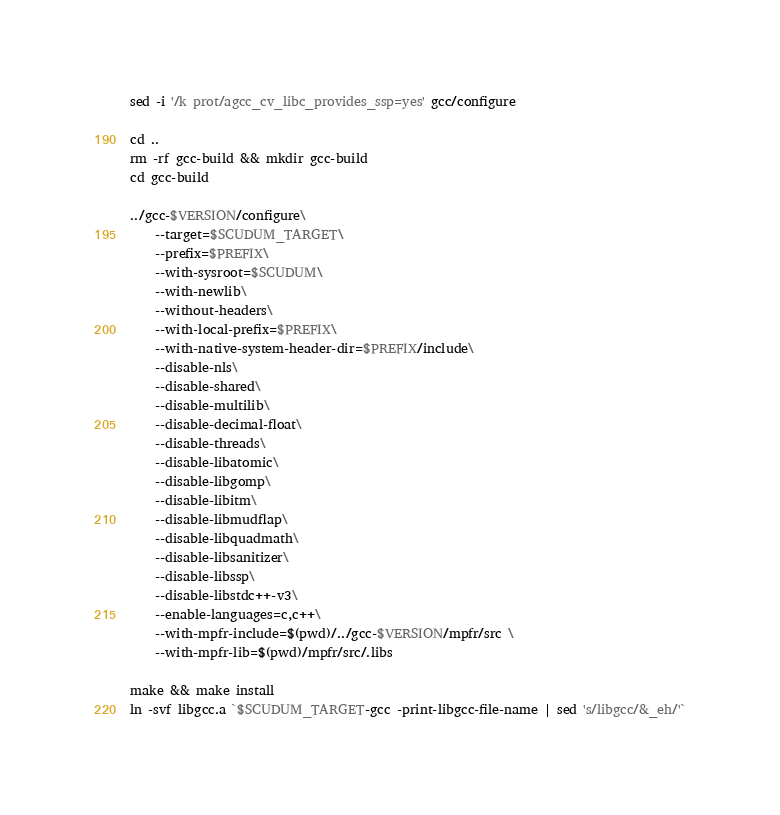<code> <loc_0><loc_0><loc_500><loc_500><_Bash_>sed -i '/k prot/agcc_cv_libc_provides_ssp=yes' gcc/configure

cd ..
rm -rf gcc-build && mkdir gcc-build
cd gcc-build

../gcc-$VERSION/configure\
    --target=$SCUDUM_TARGET\
    --prefix=$PREFIX\
    --with-sysroot=$SCUDUM\
    --with-newlib\
    --without-headers\
    --with-local-prefix=$PREFIX\
    --with-native-system-header-dir=$PREFIX/include\
    --disable-nls\
    --disable-shared\
    --disable-multilib\
    --disable-decimal-float\
    --disable-threads\
    --disable-libatomic\
    --disable-libgomp\
    --disable-libitm\
    --disable-libmudflap\
    --disable-libquadmath\
    --disable-libsanitizer\
    --disable-libssp\
    --disable-libstdc++-v3\
    --enable-languages=c,c++\
    --with-mpfr-include=$(pwd)/../gcc-$VERSION/mpfr/src \
    --with-mpfr-lib=$(pwd)/mpfr/src/.libs

make && make install
ln -svf libgcc.a `$SCUDUM_TARGET-gcc -print-libgcc-file-name | sed 's/libgcc/&_eh/'`
</code> 